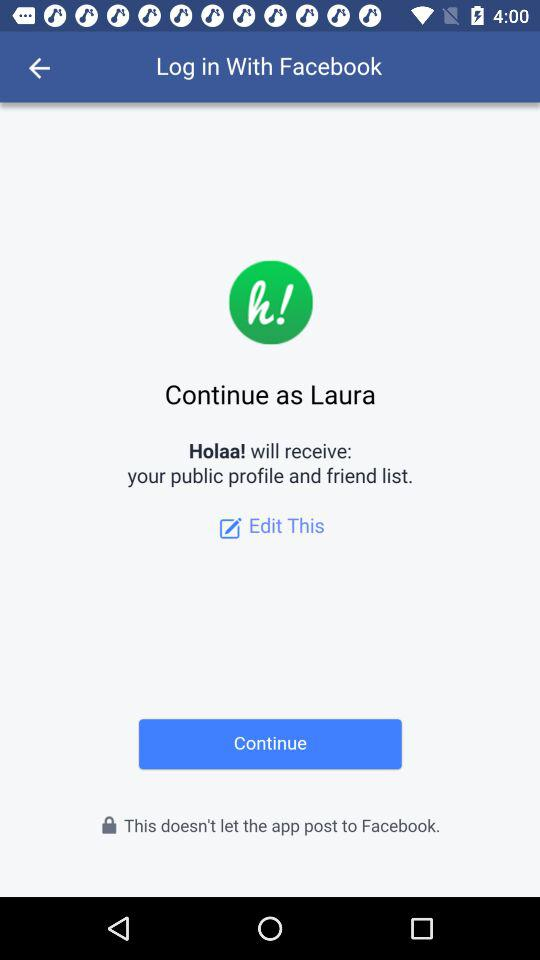What is the name of the user? The name of the user is Laura. 